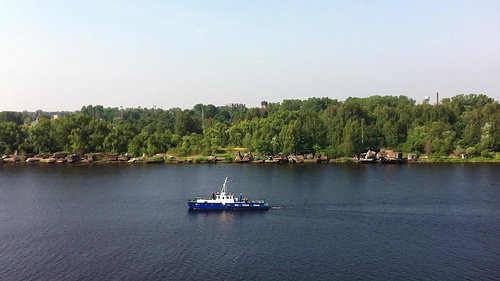Please provide the bounding box coordinate of the region this sentence describes: a small brown house. A modest brown house, possibly a quaint riverside cabin, occupies the coordinates [0.81, 0.51, 0.84, 0.55], blending subtly with the surrounding greenery. 